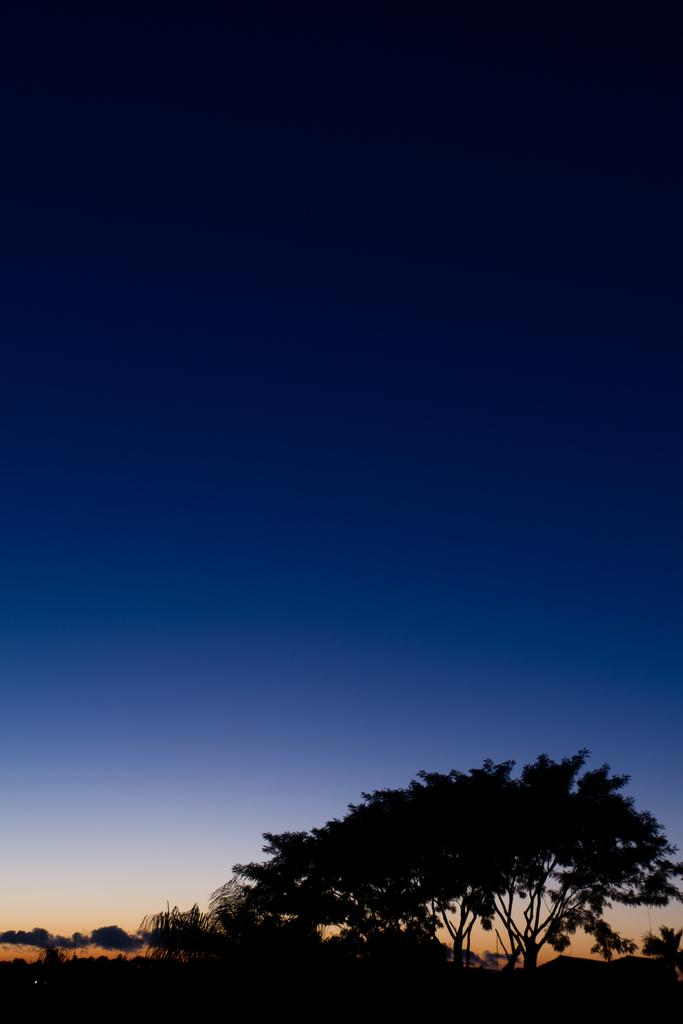What can be seen at the top of the image? The sky is visible in the image. What is the color of the sky? The color of the sky is blue. What type of vegetation is present at the bottom of the image? There are trees at the bottom of the image. Can you see a quill being used to write in the image? There is no quill or writing activity present in the image. Is there a prison visible in the image? There is no prison present in the image. 